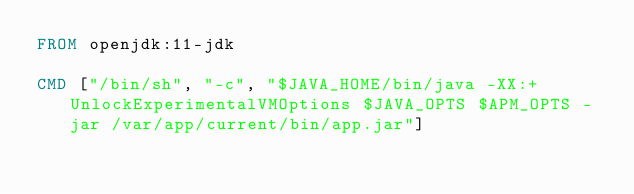Convert code to text. <code><loc_0><loc_0><loc_500><loc_500><_Dockerfile_>FROM openjdk:11-jdk

CMD ["/bin/sh", "-c", "$JAVA_HOME/bin/java -XX:+UnlockExperimentalVMOptions $JAVA_OPTS $APM_OPTS -jar /var/app/current/bin/app.jar"]
</code> 